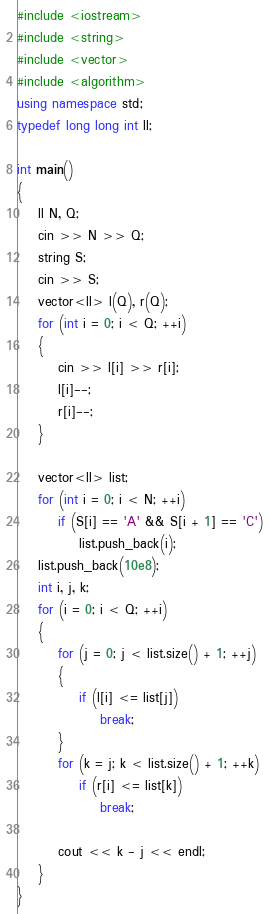Convert code to text. <code><loc_0><loc_0><loc_500><loc_500><_C++_>#include <iostream>
#include <string>
#include <vector>
#include <algorithm>
using namespace std;
typedef long long int ll;

int main()
{
    ll N, Q;
    cin >> N >> Q;
    string S;
    cin >> S;
    vector<ll> l(Q), r(Q);
    for (int i = 0; i < Q; ++i)
    {
        cin >> l[i] >> r[i];
        l[i]--;
        r[i]--;
    }

    vector<ll> list;
    for (int i = 0; i < N; ++i)
        if (S[i] == 'A' && S[i + 1] == 'C')
            list.push_back(i);
    list.push_back(10e8);
    int i, j, k;
    for (i = 0; i < Q; ++i)
    {
        for (j = 0; j < list.size() + 1; ++j)
        {
            if (l[i] <= list[j])
                break;
        }
        for (k = j; k < list.size() + 1; ++k)
            if (r[i] <= list[k])
                break;

        cout << k - j << endl;
    }
}</code> 